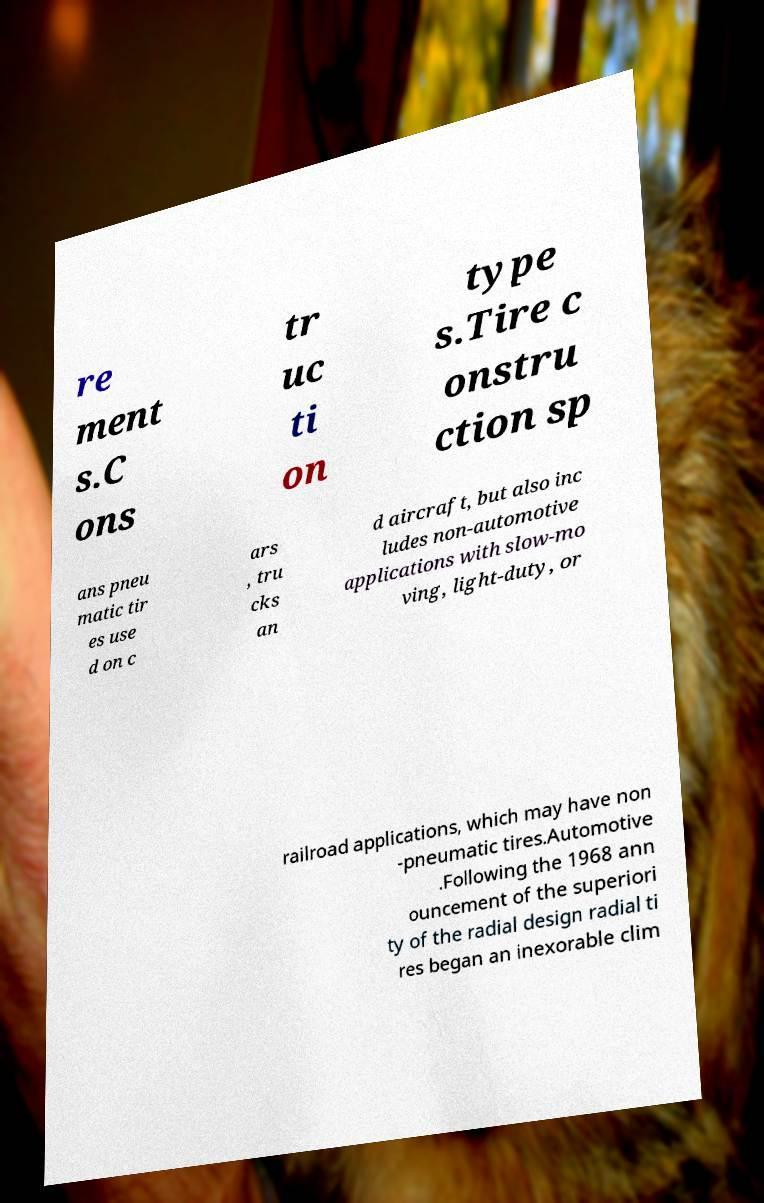There's text embedded in this image that I need extracted. Can you transcribe it verbatim? re ment s.C ons tr uc ti on type s.Tire c onstru ction sp ans pneu matic tir es use d on c ars , tru cks an d aircraft, but also inc ludes non-automotive applications with slow-mo ving, light-duty, or railroad applications, which may have non -pneumatic tires.Automotive .Following the 1968 ann ouncement of the superiori ty of the radial design radial ti res began an inexorable clim 